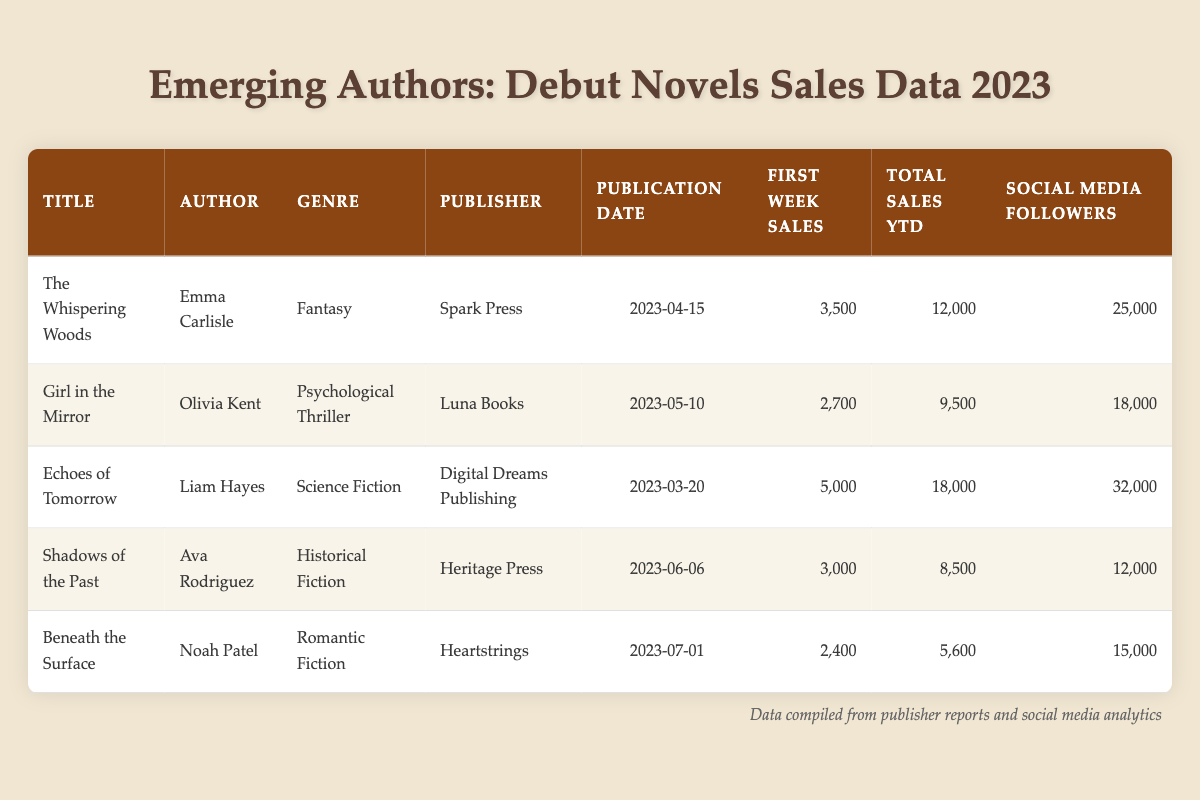What are the total sales year-to-date for "Girl in the Mirror"? According to the table, under the column for total sales year-to-date, the entry for "Girl in the Mirror" is 9,500.
Answer: 9,500 Which author has the highest first-week sales? By comparing the first-week sales figures for each title, "Echoes of Tomorrow" by Liam Hayes has the highest sales with 5,000.
Answer: Liam Hayes What is the average total sales year-to-date for all the books listed? To find the average total sales, add all the total sales: 12,000 + 9,500 + 18,000 + 8,500 + 5,600 = 53,600. Then, divide by the number of books, which is 5: 53,600 / 5 = 10,720.
Answer: 10,720 Did "The Whispering Woods" sell more copies in its first week than "Beneath the Surface"? Comparing the first-week sales figures, "The Whispering Woods" sold 3,500 while "Beneath the Surface" sold 2,400. Since 3,500 is greater than 2,400, the answer is yes.
Answer: Yes What percentage of total sales year-to-date for "Echoes of Tomorrow" comes from first-week sales? First, find the first-week sales (5,000) and the total sales year-to-date (18,000) for "Echoes of Tomorrow." Then, calculate the percentage: (5,000 / 18,000) * 100, which equals approximately 27.78%.
Answer: 27.78% 